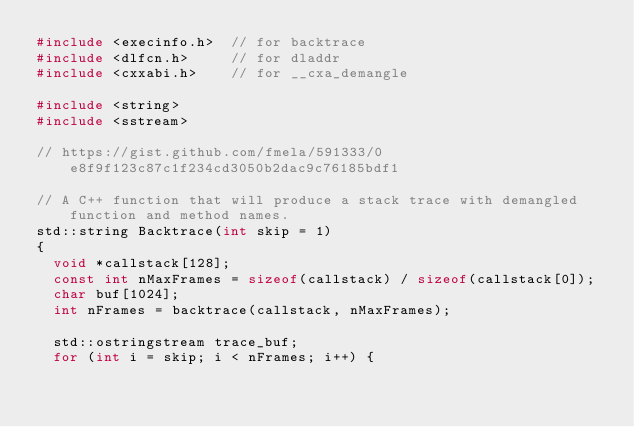Convert code to text. <code><loc_0><loc_0><loc_500><loc_500><_C++_>#include <execinfo.h>  // for backtrace
#include <dlfcn.h>     // for dladdr
#include <cxxabi.h>    // for __cxa_demangle

#include <string>
#include <sstream>

// https://gist.github.com/fmela/591333/0e8f9f123c87c1f234cd3050b2dac9c76185bdf1

// A C++ function that will produce a stack trace with demangled function and method names.
std::string Backtrace(int skip = 1)
{
	void *callstack[128];
	const int nMaxFrames = sizeof(callstack) / sizeof(callstack[0]);
	char buf[1024];
	int nFrames = backtrace(callstack, nMaxFrames);

	std::ostringstream trace_buf;
	for (int i = skip; i < nFrames; i++) {</code> 